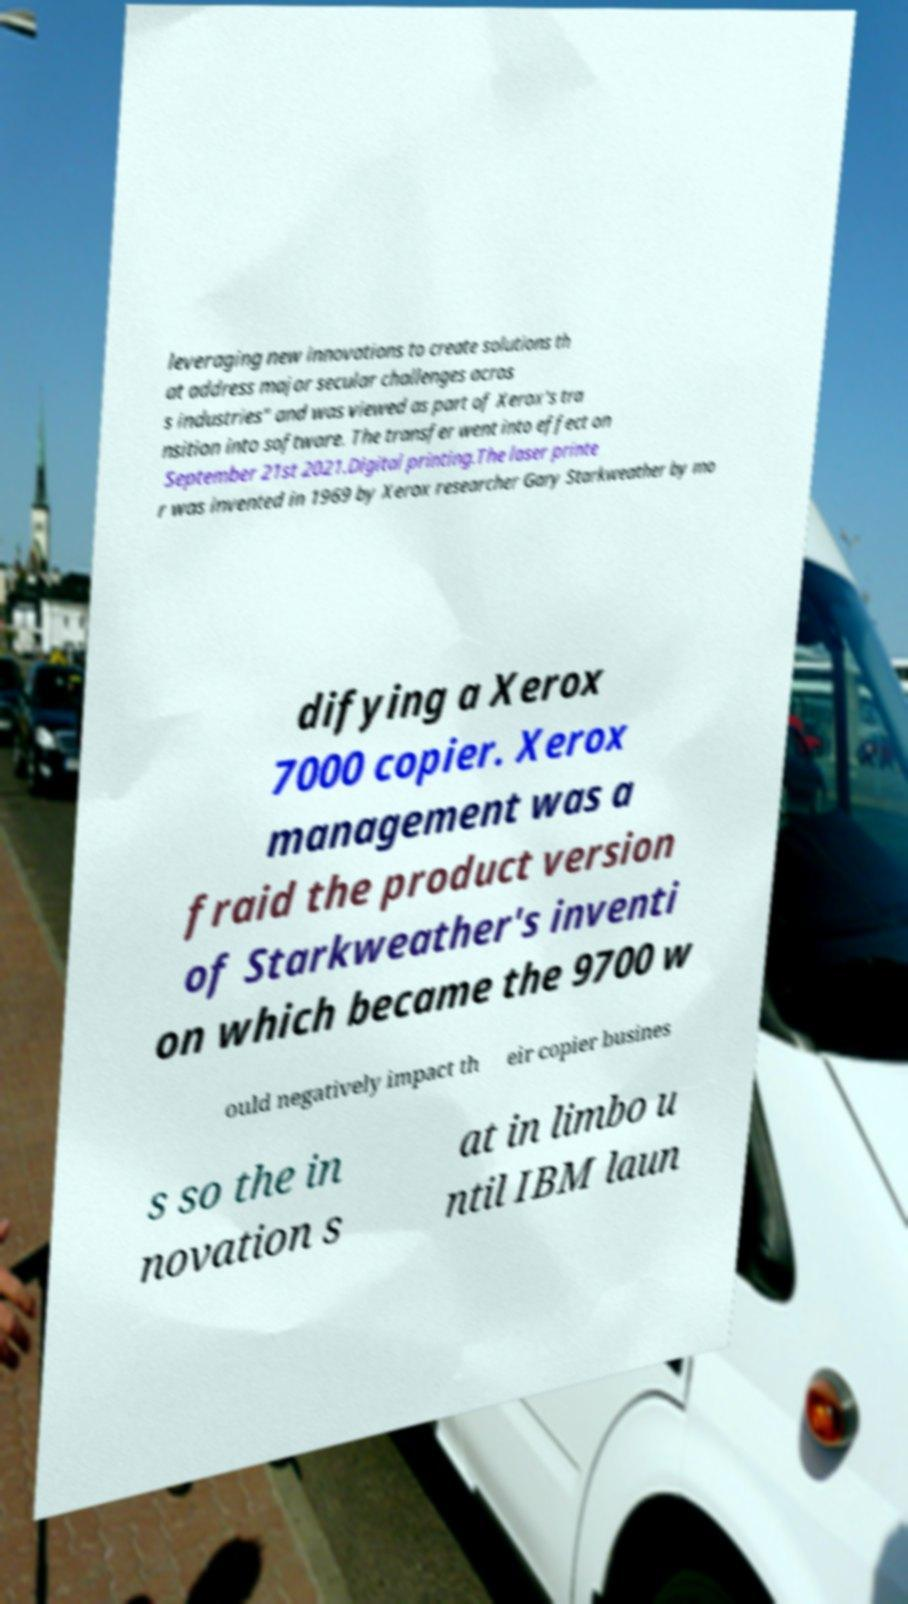Could you extract and type out the text from this image? leveraging new innovations to create solutions th at address major secular challenges acros s industries" and was viewed as part of Xerox's tra nsition into software. The transfer went into effect on September 21st 2021.Digital printing.The laser printe r was invented in 1969 by Xerox researcher Gary Starkweather by mo difying a Xerox 7000 copier. Xerox management was a fraid the product version of Starkweather's inventi on which became the 9700 w ould negatively impact th eir copier busines s so the in novation s at in limbo u ntil IBM laun 